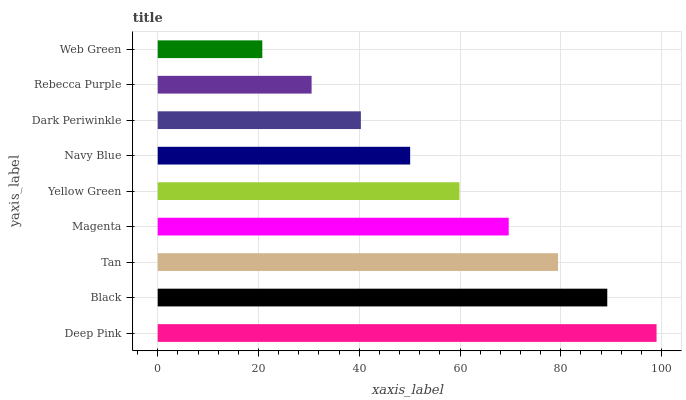Is Web Green the minimum?
Answer yes or no. Yes. Is Deep Pink the maximum?
Answer yes or no. Yes. Is Black the minimum?
Answer yes or no. No. Is Black the maximum?
Answer yes or no. No. Is Deep Pink greater than Black?
Answer yes or no. Yes. Is Black less than Deep Pink?
Answer yes or no. Yes. Is Black greater than Deep Pink?
Answer yes or no. No. Is Deep Pink less than Black?
Answer yes or no. No. Is Yellow Green the high median?
Answer yes or no. Yes. Is Yellow Green the low median?
Answer yes or no. Yes. Is Magenta the high median?
Answer yes or no. No. Is Dark Periwinkle the low median?
Answer yes or no. No. 